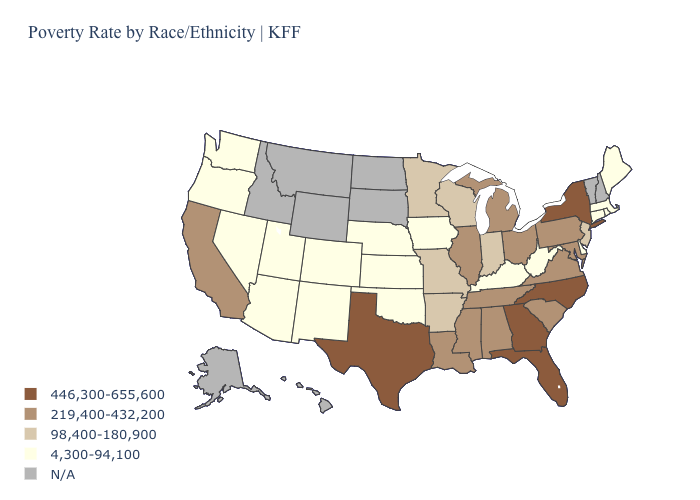What is the lowest value in states that border Wyoming?
Be succinct. 4,300-94,100. What is the lowest value in the USA?
Answer briefly. 4,300-94,100. What is the value of Pennsylvania?
Answer briefly. 219,400-432,200. What is the highest value in the USA?
Be succinct. 446,300-655,600. What is the lowest value in states that border Illinois?
Write a very short answer. 4,300-94,100. What is the lowest value in the MidWest?
Concise answer only. 4,300-94,100. Name the states that have a value in the range 219,400-432,200?
Short answer required. Alabama, California, Illinois, Louisiana, Maryland, Michigan, Mississippi, Ohio, Pennsylvania, South Carolina, Tennessee, Virginia. Name the states that have a value in the range N/A?
Be succinct. Alaska, Hawaii, Idaho, Montana, New Hampshire, North Dakota, South Dakota, Vermont, Wyoming. Which states have the lowest value in the South?
Write a very short answer. Delaware, Kentucky, Oklahoma, West Virginia. Which states hav the highest value in the Northeast?
Concise answer only. New York. Does the map have missing data?
Short answer required. Yes. Does New York have the highest value in the USA?
Be succinct. Yes. What is the value of Louisiana?
Quick response, please. 219,400-432,200. Does New York have the highest value in the Northeast?
Keep it brief. Yes. 